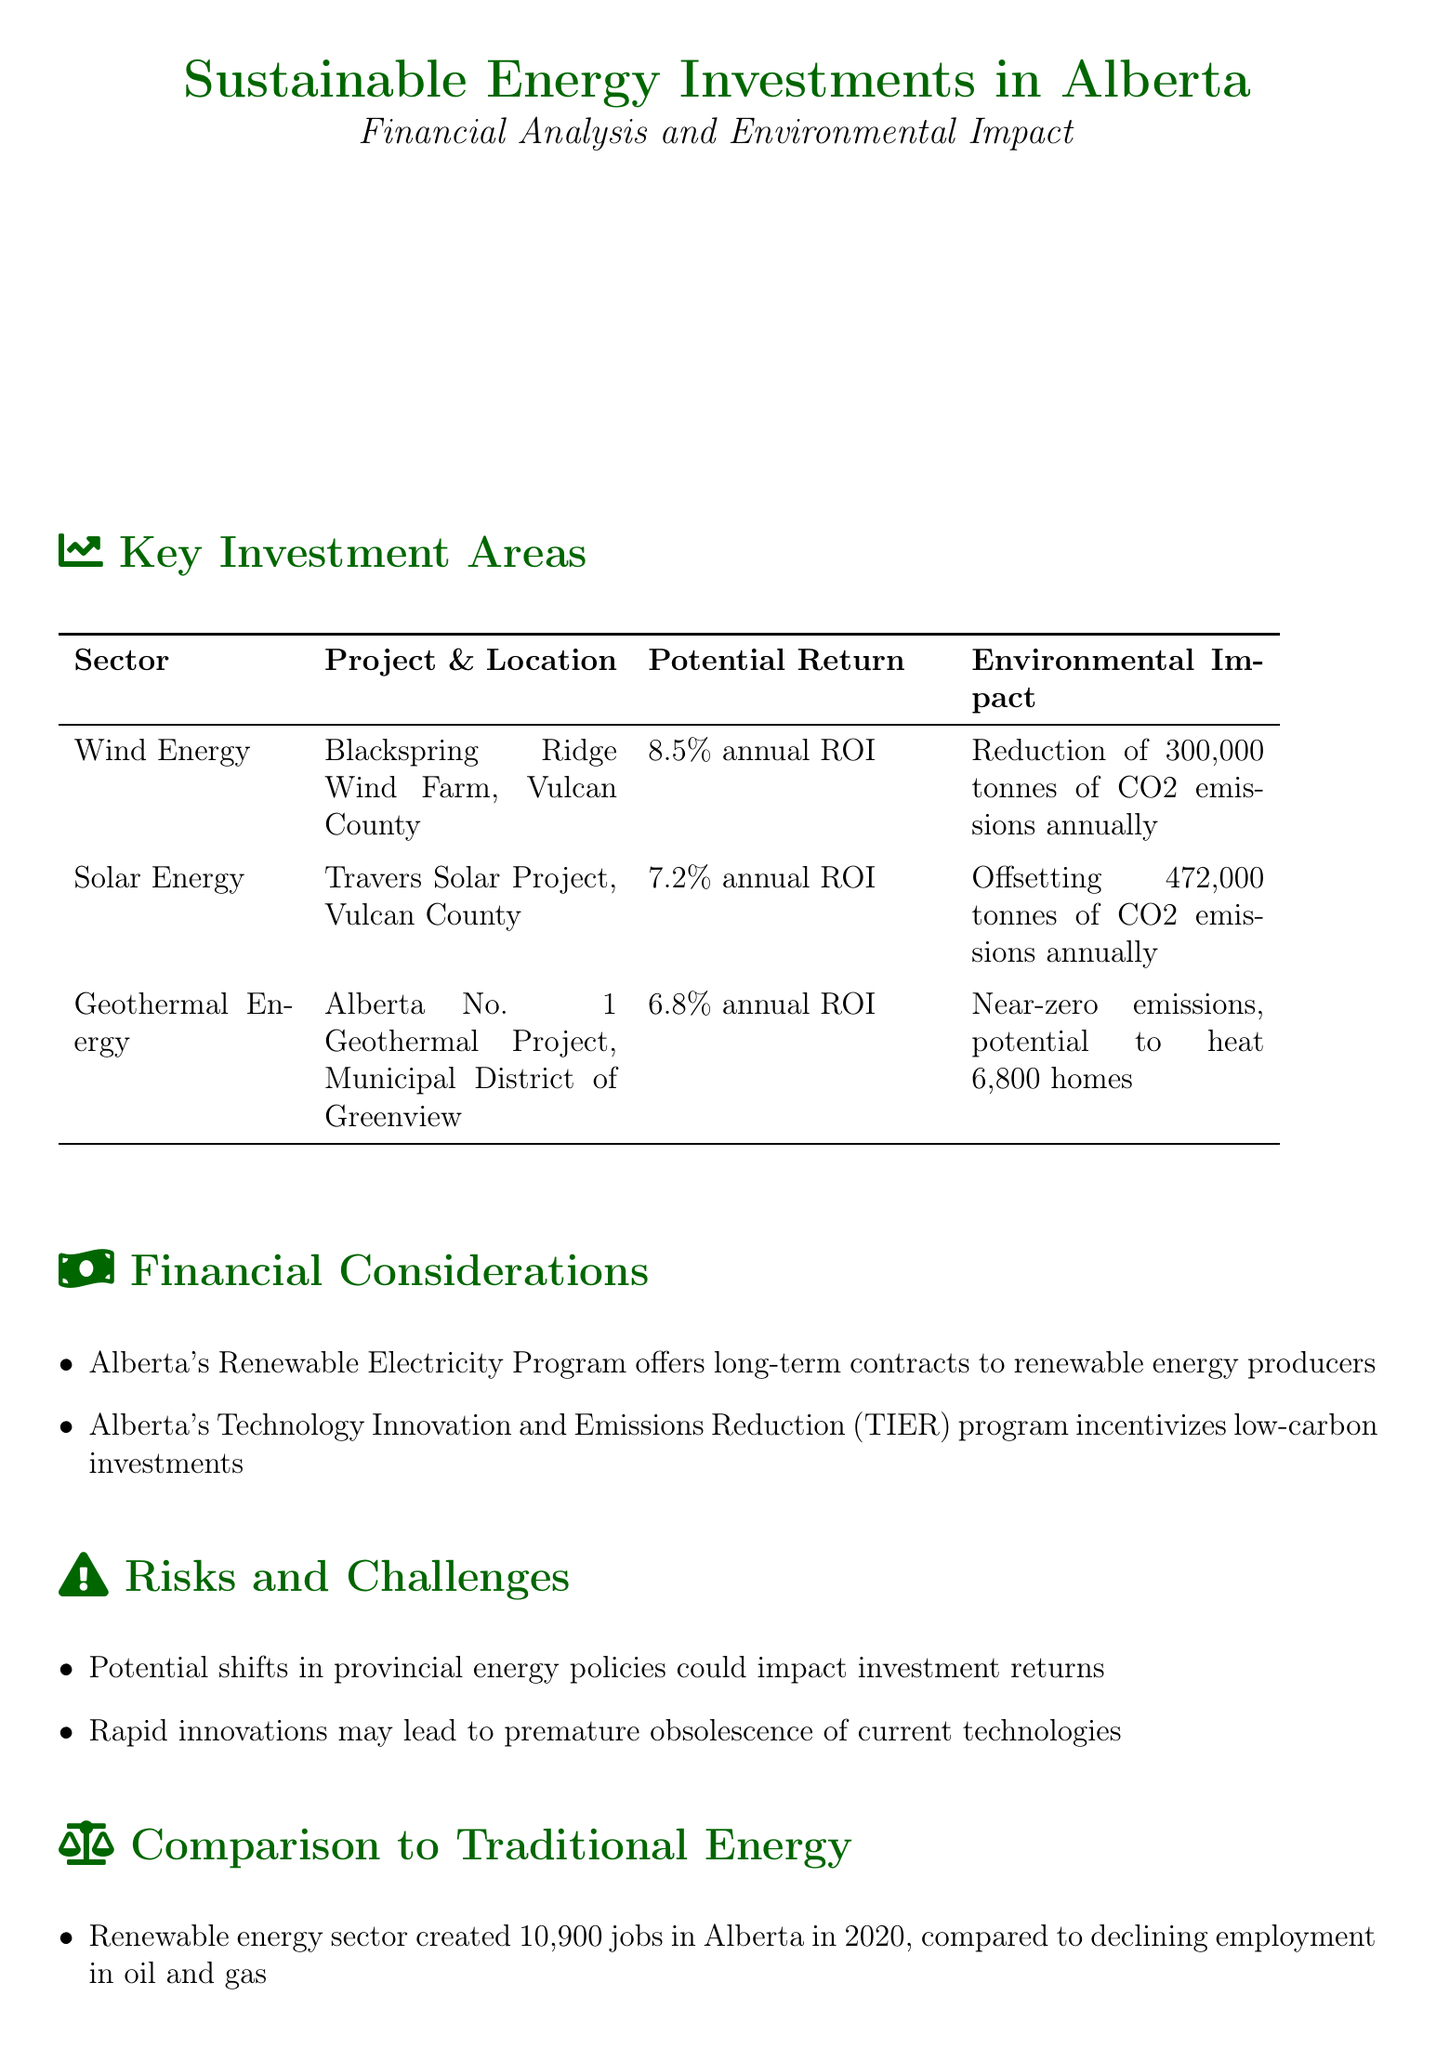What is the annual ROI for the Blackspring Ridge Wind Farm? The annual ROI for the Blackspring Ridge Wind Farm is specified in the document under key investment areas.
Answer: 8.5% What is the environmental impact of the Travers Solar Project? The environmental impact of the Travers Solar Project is stated as offsetting a specific amount of CO2 emissions.
Answer: Offsetting 472,000 tonnes of CO2 emissions annually How many jobs did the renewable energy sector create in Alberta in 2020? The document specifies the number of jobs created by the renewable energy sector in Alberta in 2020 under the comparison to traditional energy section.
Answer: 10,900 jobs What is the potential to heat homes in the Alberta No. 1 Geothermal Project? This information regarding the geothermal project is provided in the key investment areas section.
Answer: Potential to heat 6,800 homes What government program offers long-term contracts to renewable energy producers? The document mentions the name of the program under financial considerations.
Answer: Alberta's Renewable Electricity Program What type of energy investments offer more stable returns compared to commodity-based industries? This type of investment is discussed under the comparison to traditional energy section.
Answer: Sustainable energy investments What are the risks associated with investment returns mentioned in the report? The document lists specific risks that may affect investment returns in the risks and challenges section.
Answer: Regulatory changes Which location is home to the Travers Solar Project? The location of the Travers Solar Project is provided in the key investment areas section.
Answer: Vulcan County 